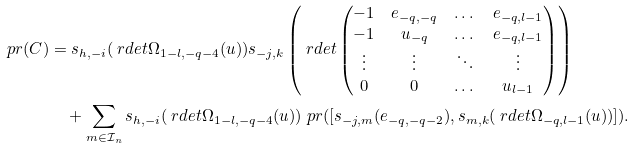<formula> <loc_0><loc_0><loc_500><loc_500>\ p r ( C ) & = s _ { h , - i } ( \ r d e t \Omega _ { 1 - l , - q - 4 } ( u ) ) s _ { - j , k } \left ( \ r d e t \begin{pmatrix} - 1 & e _ { - q , - q } & \dots & e _ { - q , l - 1 } \\ - 1 & u _ { - q } & \dots & e _ { - q , l - 1 } \\ \vdots & \vdots & \ddots & \vdots \\ 0 & 0 & \dots & u _ { l - 1 } \end{pmatrix} \right ) \\ & \quad + \sum _ { m \in \mathcal { I } _ { n } } s _ { h , - i } ( \ r d e t \Omega _ { 1 - l , - q - 4 } ( u ) ) \ p r ( [ s _ { - j , m } ( e _ { - q , - q - 2 } ) , s _ { m , k } ( \ r d e t \Omega _ { - q , l - 1 } ( u ) ) ] ) .</formula> 